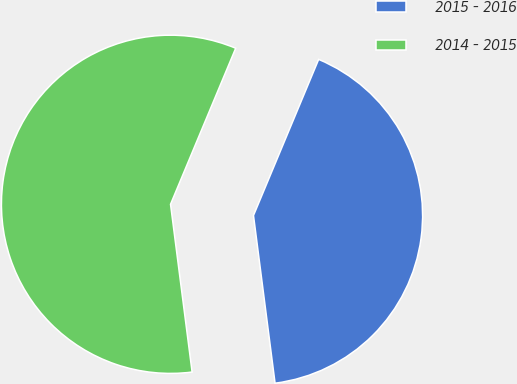<chart> <loc_0><loc_0><loc_500><loc_500><pie_chart><fcel>2015 - 2016<fcel>2014 - 2015<nl><fcel>41.67%<fcel>58.33%<nl></chart> 